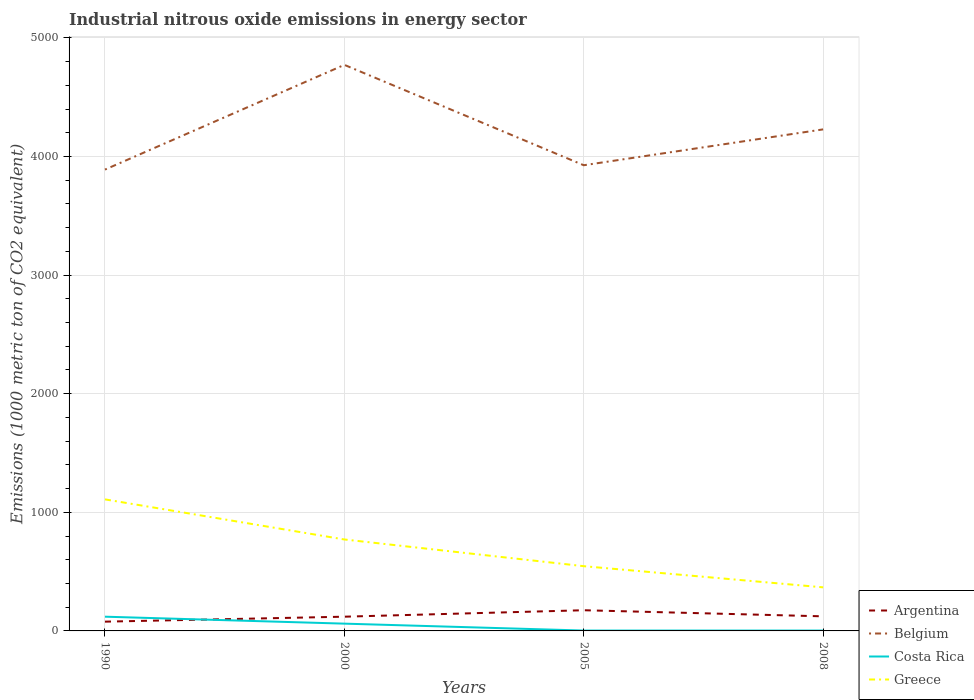Does the line corresponding to Belgium intersect with the line corresponding to Costa Rica?
Ensure brevity in your answer.  No. Is the number of lines equal to the number of legend labels?
Provide a short and direct response. Yes. Across all years, what is the maximum amount of industrial nitrous oxide emitted in Greece?
Offer a terse response. 367.4. What is the total amount of industrial nitrous oxide emitted in Belgium in the graph?
Keep it short and to the point. -339. What is the difference between the highest and the second highest amount of industrial nitrous oxide emitted in Greece?
Give a very brief answer. 741.7. How many years are there in the graph?
Give a very brief answer. 4. What is the difference between two consecutive major ticks on the Y-axis?
Make the answer very short. 1000. Does the graph contain grids?
Your answer should be compact. Yes. What is the title of the graph?
Offer a very short reply. Industrial nitrous oxide emissions in energy sector. What is the label or title of the X-axis?
Your response must be concise. Years. What is the label or title of the Y-axis?
Provide a succinct answer. Emissions (1000 metric ton of CO2 equivalent). What is the Emissions (1000 metric ton of CO2 equivalent) of Argentina in 1990?
Offer a very short reply. 78.1. What is the Emissions (1000 metric ton of CO2 equivalent) of Belgium in 1990?
Your answer should be very brief. 3889.6. What is the Emissions (1000 metric ton of CO2 equivalent) of Costa Rica in 1990?
Keep it short and to the point. 120. What is the Emissions (1000 metric ton of CO2 equivalent) of Greece in 1990?
Offer a very short reply. 1109.1. What is the Emissions (1000 metric ton of CO2 equivalent) of Argentina in 2000?
Your answer should be very brief. 120. What is the Emissions (1000 metric ton of CO2 equivalent) in Belgium in 2000?
Offer a terse response. 4772.6. What is the Emissions (1000 metric ton of CO2 equivalent) in Costa Rica in 2000?
Provide a short and direct response. 61.4. What is the Emissions (1000 metric ton of CO2 equivalent) in Greece in 2000?
Give a very brief answer. 771. What is the Emissions (1000 metric ton of CO2 equivalent) in Argentina in 2005?
Give a very brief answer. 174.4. What is the Emissions (1000 metric ton of CO2 equivalent) in Belgium in 2005?
Keep it short and to the point. 3926.3. What is the Emissions (1000 metric ton of CO2 equivalent) of Costa Rica in 2005?
Provide a short and direct response. 3.1. What is the Emissions (1000 metric ton of CO2 equivalent) of Greece in 2005?
Give a very brief answer. 545.8. What is the Emissions (1000 metric ton of CO2 equivalent) in Argentina in 2008?
Provide a short and direct response. 123. What is the Emissions (1000 metric ton of CO2 equivalent) of Belgium in 2008?
Offer a terse response. 4228.6. What is the Emissions (1000 metric ton of CO2 equivalent) in Greece in 2008?
Make the answer very short. 367.4. Across all years, what is the maximum Emissions (1000 metric ton of CO2 equivalent) of Argentina?
Offer a very short reply. 174.4. Across all years, what is the maximum Emissions (1000 metric ton of CO2 equivalent) in Belgium?
Offer a very short reply. 4772.6. Across all years, what is the maximum Emissions (1000 metric ton of CO2 equivalent) in Costa Rica?
Offer a terse response. 120. Across all years, what is the maximum Emissions (1000 metric ton of CO2 equivalent) in Greece?
Offer a very short reply. 1109.1. Across all years, what is the minimum Emissions (1000 metric ton of CO2 equivalent) in Argentina?
Your answer should be very brief. 78.1. Across all years, what is the minimum Emissions (1000 metric ton of CO2 equivalent) of Belgium?
Ensure brevity in your answer.  3889.6. Across all years, what is the minimum Emissions (1000 metric ton of CO2 equivalent) of Costa Rica?
Your answer should be very brief. 3.1. Across all years, what is the minimum Emissions (1000 metric ton of CO2 equivalent) in Greece?
Keep it short and to the point. 367.4. What is the total Emissions (1000 metric ton of CO2 equivalent) in Argentina in the graph?
Offer a terse response. 495.5. What is the total Emissions (1000 metric ton of CO2 equivalent) of Belgium in the graph?
Provide a succinct answer. 1.68e+04. What is the total Emissions (1000 metric ton of CO2 equivalent) in Costa Rica in the graph?
Offer a terse response. 187.6. What is the total Emissions (1000 metric ton of CO2 equivalent) of Greece in the graph?
Your answer should be very brief. 2793.3. What is the difference between the Emissions (1000 metric ton of CO2 equivalent) of Argentina in 1990 and that in 2000?
Your answer should be very brief. -41.9. What is the difference between the Emissions (1000 metric ton of CO2 equivalent) in Belgium in 1990 and that in 2000?
Provide a short and direct response. -883. What is the difference between the Emissions (1000 metric ton of CO2 equivalent) of Costa Rica in 1990 and that in 2000?
Ensure brevity in your answer.  58.6. What is the difference between the Emissions (1000 metric ton of CO2 equivalent) in Greece in 1990 and that in 2000?
Make the answer very short. 338.1. What is the difference between the Emissions (1000 metric ton of CO2 equivalent) of Argentina in 1990 and that in 2005?
Your answer should be very brief. -96.3. What is the difference between the Emissions (1000 metric ton of CO2 equivalent) of Belgium in 1990 and that in 2005?
Offer a very short reply. -36.7. What is the difference between the Emissions (1000 metric ton of CO2 equivalent) in Costa Rica in 1990 and that in 2005?
Your answer should be compact. 116.9. What is the difference between the Emissions (1000 metric ton of CO2 equivalent) in Greece in 1990 and that in 2005?
Your response must be concise. 563.3. What is the difference between the Emissions (1000 metric ton of CO2 equivalent) of Argentina in 1990 and that in 2008?
Offer a terse response. -44.9. What is the difference between the Emissions (1000 metric ton of CO2 equivalent) in Belgium in 1990 and that in 2008?
Your answer should be compact. -339. What is the difference between the Emissions (1000 metric ton of CO2 equivalent) in Costa Rica in 1990 and that in 2008?
Offer a terse response. 116.9. What is the difference between the Emissions (1000 metric ton of CO2 equivalent) of Greece in 1990 and that in 2008?
Give a very brief answer. 741.7. What is the difference between the Emissions (1000 metric ton of CO2 equivalent) in Argentina in 2000 and that in 2005?
Give a very brief answer. -54.4. What is the difference between the Emissions (1000 metric ton of CO2 equivalent) of Belgium in 2000 and that in 2005?
Offer a terse response. 846.3. What is the difference between the Emissions (1000 metric ton of CO2 equivalent) of Costa Rica in 2000 and that in 2005?
Keep it short and to the point. 58.3. What is the difference between the Emissions (1000 metric ton of CO2 equivalent) in Greece in 2000 and that in 2005?
Offer a very short reply. 225.2. What is the difference between the Emissions (1000 metric ton of CO2 equivalent) in Belgium in 2000 and that in 2008?
Your answer should be compact. 544. What is the difference between the Emissions (1000 metric ton of CO2 equivalent) of Costa Rica in 2000 and that in 2008?
Offer a terse response. 58.3. What is the difference between the Emissions (1000 metric ton of CO2 equivalent) in Greece in 2000 and that in 2008?
Your answer should be compact. 403.6. What is the difference between the Emissions (1000 metric ton of CO2 equivalent) in Argentina in 2005 and that in 2008?
Provide a short and direct response. 51.4. What is the difference between the Emissions (1000 metric ton of CO2 equivalent) of Belgium in 2005 and that in 2008?
Keep it short and to the point. -302.3. What is the difference between the Emissions (1000 metric ton of CO2 equivalent) in Costa Rica in 2005 and that in 2008?
Give a very brief answer. 0. What is the difference between the Emissions (1000 metric ton of CO2 equivalent) of Greece in 2005 and that in 2008?
Give a very brief answer. 178.4. What is the difference between the Emissions (1000 metric ton of CO2 equivalent) of Argentina in 1990 and the Emissions (1000 metric ton of CO2 equivalent) of Belgium in 2000?
Offer a terse response. -4694.5. What is the difference between the Emissions (1000 metric ton of CO2 equivalent) of Argentina in 1990 and the Emissions (1000 metric ton of CO2 equivalent) of Costa Rica in 2000?
Keep it short and to the point. 16.7. What is the difference between the Emissions (1000 metric ton of CO2 equivalent) of Argentina in 1990 and the Emissions (1000 metric ton of CO2 equivalent) of Greece in 2000?
Provide a short and direct response. -692.9. What is the difference between the Emissions (1000 metric ton of CO2 equivalent) of Belgium in 1990 and the Emissions (1000 metric ton of CO2 equivalent) of Costa Rica in 2000?
Provide a succinct answer. 3828.2. What is the difference between the Emissions (1000 metric ton of CO2 equivalent) of Belgium in 1990 and the Emissions (1000 metric ton of CO2 equivalent) of Greece in 2000?
Offer a very short reply. 3118.6. What is the difference between the Emissions (1000 metric ton of CO2 equivalent) of Costa Rica in 1990 and the Emissions (1000 metric ton of CO2 equivalent) of Greece in 2000?
Provide a succinct answer. -651. What is the difference between the Emissions (1000 metric ton of CO2 equivalent) in Argentina in 1990 and the Emissions (1000 metric ton of CO2 equivalent) in Belgium in 2005?
Ensure brevity in your answer.  -3848.2. What is the difference between the Emissions (1000 metric ton of CO2 equivalent) in Argentina in 1990 and the Emissions (1000 metric ton of CO2 equivalent) in Costa Rica in 2005?
Offer a terse response. 75. What is the difference between the Emissions (1000 metric ton of CO2 equivalent) of Argentina in 1990 and the Emissions (1000 metric ton of CO2 equivalent) of Greece in 2005?
Your answer should be compact. -467.7. What is the difference between the Emissions (1000 metric ton of CO2 equivalent) of Belgium in 1990 and the Emissions (1000 metric ton of CO2 equivalent) of Costa Rica in 2005?
Make the answer very short. 3886.5. What is the difference between the Emissions (1000 metric ton of CO2 equivalent) in Belgium in 1990 and the Emissions (1000 metric ton of CO2 equivalent) in Greece in 2005?
Make the answer very short. 3343.8. What is the difference between the Emissions (1000 metric ton of CO2 equivalent) of Costa Rica in 1990 and the Emissions (1000 metric ton of CO2 equivalent) of Greece in 2005?
Keep it short and to the point. -425.8. What is the difference between the Emissions (1000 metric ton of CO2 equivalent) of Argentina in 1990 and the Emissions (1000 metric ton of CO2 equivalent) of Belgium in 2008?
Ensure brevity in your answer.  -4150.5. What is the difference between the Emissions (1000 metric ton of CO2 equivalent) in Argentina in 1990 and the Emissions (1000 metric ton of CO2 equivalent) in Costa Rica in 2008?
Offer a very short reply. 75. What is the difference between the Emissions (1000 metric ton of CO2 equivalent) of Argentina in 1990 and the Emissions (1000 metric ton of CO2 equivalent) of Greece in 2008?
Ensure brevity in your answer.  -289.3. What is the difference between the Emissions (1000 metric ton of CO2 equivalent) in Belgium in 1990 and the Emissions (1000 metric ton of CO2 equivalent) in Costa Rica in 2008?
Give a very brief answer. 3886.5. What is the difference between the Emissions (1000 metric ton of CO2 equivalent) of Belgium in 1990 and the Emissions (1000 metric ton of CO2 equivalent) of Greece in 2008?
Your response must be concise. 3522.2. What is the difference between the Emissions (1000 metric ton of CO2 equivalent) of Costa Rica in 1990 and the Emissions (1000 metric ton of CO2 equivalent) of Greece in 2008?
Offer a terse response. -247.4. What is the difference between the Emissions (1000 metric ton of CO2 equivalent) of Argentina in 2000 and the Emissions (1000 metric ton of CO2 equivalent) of Belgium in 2005?
Offer a terse response. -3806.3. What is the difference between the Emissions (1000 metric ton of CO2 equivalent) in Argentina in 2000 and the Emissions (1000 metric ton of CO2 equivalent) in Costa Rica in 2005?
Ensure brevity in your answer.  116.9. What is the difference between the Emissions (1000 metric ton of CO2 equivalent) of Argentina in 2000 and the Emissions (1000 metric ton of CO2 equivalent) of Greece in 2005?
Offer a very short reply. -425.8. What is the difference between the Emissions (1000 metric ton of CO2 equivalent) of Belgium in 2000 and the Emissions (1000 metric ton of CO2 equivalent) of Costa Rica in 2005?
Offer a very short reply. 4769.5. What is the difference between the Emissions (1000 metric ton of CO2 equivalent) in Belgium in 2000 and the Emissions (1000 metric ton of CO2 equivalent) in Greece in 2005?
Give a very brief answer. 4226.8. What is the difference between the Emissions (1000 metric ton of CO2 equivalent) of Costa Rica in 2000 and the Emissions (1000 metric ton of CO2 equivalent) of Greece in 2005?
Give a very brief answer. -484.4. What is the difference between the Emissions (1000 metric ton of CO2 equivalent) of Argentina in 2000 and the Emissions (1000 metric ton of CO2 equivalent) of Belgium in 2008?
Offer a terse response. -4108.6. What is the difference between the Emissions (1000 metric ton of CO2 equivalent) of Argentina in 2000 and the Emissions (1000 metric ton of CO2 equivalent) of Costa Rica in 2008?
Your answer should be compact. 116.9. What is the difference between the Emissions (1000 metric ton of CO2 equivalent) in Argentina in 2000 and the Emissions (1000 metric ton of CO2 equivalent) in Greece in 2008?
Your answer should be compact. -247.4. What is the difference between the Emissions (1000 metric ton of CO2 equivalent) of Belgium in 2000 and the Emissions (1000 metric ton of CO2 equivalent) of Costa Rica in 2008?
Keep it short and to the point. 4769.5. What is the difference between the Emissions (1000 metric ton of CO2 equivalent) of Belgium in 2000 and the Emissions (1000 metric ton of CO2 equivalent) of Greece in 2008?
Ensure brevity in your answer.  4405.2. What is the difference between the Emissions (1000 metric ton of CO2 equivalent) in Costa Rica in 2000 and the Emissions (1000 metric ton of CO2 equivalent) in Greece in 2008?
Give a very brief answer. -306. What is the difference between the Emissions (1000 metric ton of CO2 equivalent) in Argentina in 2005 and the Emissions (1000 metric ton of CO2 equivalent) in Belgium in 2008?
Your answer should be compact. -4054.2. What is the difference between the Emissions (1000 metric ton of CO2 equivalent) in Argentina in 2005 and the Emissions (1000 metric ton of CO2 equivalent) in Costa Rica in 2008?
Keep it short and to the point. 171.3. What is the difference between the Emissions (1000 metric ton of CO2 equivalent) of Argentina in 2005 and the Emissions (1000 metric ton of CO2 equivalent) of Greece in 2008?
Provide a succinct answer. -193. What is the difference between the Emissions (1000 metric ton of CO2 equivalent) of Belgium in 2005 and the Emissions (1000 metric ton of CO2 equivalent) of Costa Rica in 2008?
Keep it short and to the point. 3923.2. What is the difference between the Emissions (1000 metric ton of CO2 equivalent) of Belgium in 2005 and the Emissions (1000 metric ton of CO2 equivalent) of Greece in 2008?
Provide a short and direct response. 3558.9. What is the difference between the Emissions (1000 metric ton of CO2 equivalent) in Costa Rica in 2005 and the Emissions (1000 metric ton of CO2 equivalent) in Greece in 2008?
Provide a succinct answer. -364.3. What is the average Emissions (1000 metric ton of CO2 equivalent) of Argentina per year?
Make the answer very short. 123.88. What is the average Emissions (1000 metric ton of CO2 equivalent) of Belgium per year?
Provide a short and direct response. 4204.27. What is the average Emissions (1000 metric ton of CO2 equivalent) of Costa Rica per year?
Your answer should be very brief. 46.9. What is the average Emissions (1000 metric ton of CO2 equivalent) in Greece per year?
Offer a terse response. 698.33. In the year 1990, what is the difference between the Emissions (1000 metric ton of CO2 equivalent) in Argentina and Emissions (1000 metric ton of CO2 equivalent) in Belgium?
Keep it short and to the point. -3811.5. In the year 1990, what is the difference between the Emissions (1000 metric ton of CO2 equivalent) of Argentina and Emissions (1000 metric ton of CO2 equivalent) of Costa Rica?
Ensure brevity in your answer.  -41.9. In the year 1990, what is the difference between the Emissions (1000 metric ton of CO2 equivalent) of Argentina and Emissions (1000 metric ton of CO2 equivalent) of Greece?
Offer a very short reply. -1031. In the year 1990, what is the difference between the Emissions (1000 metric ton of CO2 equivalent) in Belgium and Emissions (1000 metric ton of CO2 equivalent) in Costa Rica?
Offer a terse response. 3769.6. In the year 1990, what is the difference between the Emissions (1000 metric ton of CO2 equivalent) of Belgium and Emissions (1000 metric ton of CO2 equivalent) of Greece?
Your response must be concise. 2780.5. In the year 1990, what is the difference between the Emissions (1000 metric ton of CO2 equivalent) of Costa Rica and Emissions (1000 metric ton of CO2 equivalent) of Greece?
Provide a succinct answer. -989.1. In the year 2000, what is the difference between the Emissions (1000 metric ton of CO2 equivalent) in Argentina and Emissions (1000 metric ton of CO2 equivalent) in Belgium?
Ensure brevity in your answer.  -4652.6. In the year 2000, what is the difference between the Emissions (1000 metric ton of CO2 equivalent) in Argentina and Emissions (1000 metric ton of CO2 equivalent) in Costa Rica?
Your answer should be very brief. 58.6. In the year 2000, what is the difference between the Emissions (1000 metric ton of CO2 equivalent) in Argentina and Emissions (1000 metric ton of CO2 equivalent) in Greece?
Offer a terse response. -651. In the year 2000, what is the difference between the Emissions (1000 metric ton of CO2 equivalent) of Belgium and Emissions (1000 metric ton of CO2 equivalent) of Costa Rica?
Keep it short and to the point. 4711.2. In the year 2000, what is the difference between the Emissions (1000 metric ton of CO2 equivalent) in Belgium and Emissions (1000 metric ton of CO2 equivalent) in Greece?
Provide a succinct answer. 4001.6. In the year 2000, what is the difference between the Emissions (1000 metric ton of CO2 equivalent) of Costa Rica and Emissions (1000 metric ton of CO2 equivalent) of Greece?
Offer a very short reply. -709.6. In the year 2005, what is the difference between the Emissions (1000 metric ton of CO2 equivalent) of Argentina and Emissions (1000 metric ton of CO2 equivalent) of Belgium?
Offer a very short reply. -3751.9. In the year 2005, what is the difference between the Emissions (1000 metric ton of CO2 equivalent) in Argentina and Emissions (1000 metric ton of CO2 equivalent) in Costa Rica?
Your response must be concise. 171.3. In the year 2005, what is the difference between the Emissions (1000 metric ton of CO2 equivalent) of Argentina and Emissions (1000 metric ton of CO2 equivalent) of Greece?
Make the answer very short. -371.4. In the year 2005, what is the difference between the Emissions (1000 metric ton of CO2 equivalent) in Belgium and Emissions (1000 metric ton of CO2 equivalent) in Costa Rica?
Ensure brevity in your answer.  3923.2. In the year 2005, what is the difference between the Emissions (1000 metric ton of CO2 equivalent) in Belgium and Emissions (1000 metric ton of CO2 equivalent) in Greece?
Offer a terse response. 3380.5. In the year 2005, what is the difference between the Emissions (1000 metric ton of CO2 equivalent) of Costa Rica and Emissions (1000 metric ton of CO2 equivalent) of Greece?
Offer a very short reply. -542.7. In the year 2008, what is the difference between the Emissions (1000 metric ton of CO2 equivalent) of Argentina and Emissions (1000 metric ton of CO2 equivalent) of Belgium?
Offer a very short reply. -4105.6. In the year 2008, what is the difference between the Emissions (1000 metric ton of CO2 equivalent) in Argentina and Emissions (1000 metric ton of CO2 equivalent) in Costa Rica?
Keep it short and to the point. 119.9. In the year 2008, what is the difference between the Emissions (1000 metric ton of CO2 equivalent) in Argentina and Emissions (1000 metric ton of CO2 equivalent) in Greece?
Keep it short and to the point. -244.4. In the year 2008, what is the difference between the Emissions (1000 metric ton of CO2 equivalent) of Belgium and Emissions (1000 metric ton of CO2 equivalent) of Costa Rica?
Offer a terse response. 4225.5. In the year 2008, what is the difference between the Emissions (1000 metric ton of CO2 equivalent) of Belgium and Emissions (1000 metric ton of CO2 equivalent) of Greece?
Give a very brief answer. 3861.2. In the year 2008, what is the difference between the Emissions (1000 metric ton of CO2 equivalent) of Costa Rica and Emissions (1000 metric ton of CO2 equivalent) of Greece?
Offer a terse response. -364.3. What is the ratio of the Emissions (1000 metric ton of CO2 equivalent) in Argentina in 1990 to that in 2000?
Your answer should be very brief. 0.65. What is the ratio of the Emissions (1000 metric ton of CO2 equivalent) in Belgium in 1990 to that in 2000?
Ensure brevity in your answer.  0.81. What is the ratio of the Emissions (1000 metric ton of CO2 equivalent) in Costa Rica in 1990 to that in 2000?
Provide a succinct answer. 1.95. What is the ratio of the Emissions (1000 metric ton of CO2 equivalent) of Greece in 1990 to that in 2000?
Your answer should be very brief. 1.44. What is the ratio of the Emissions (1000 metric ton of CO2 equivalent) of Argentina in 1990 to that in 2005?
Offer a very short reply. 0.45. What is the ratio of the Emissions (1000 metric ton of CO2 equivalent) of Costa Rica in 1990 to that in 2005?
Ensure brevity in your answer.  38.71. What is the ratio of the Emissions (1000 metric ton of CO2 equivalent) in Greece in 1990 to that in 2005?
Offer a very short reply. 2.03. What is the ratio of the Emissions (1000 metric ton of CO2 equivalent) in Argentina in 1990 to that in 2008?
Offer a very short reply. 0.64. What is the ratio of the Emissions (1000 metric ton of CO2 equivalent) of Belgium in 1990 to that in 2008?
Provide a succinct answer. 0.92. What is the ratio of the Emissions (1000 metric ton of CO2 equivalent) in Costa Rica in 1990 to that in 2008?
Provide a succinct answer. 38.71. What is the ratio of the Emissions (1000 metric ton of CO2 equivalent) in Greece in 1990 to that in 2008?
Your answer should be compact. 3.02. What is the ratio of the Emissions (1000 metric ton of CO2 equivalent) in Argentina in 2000 to that in 2005?
Offer a terse response. 0.69. What is the ratio of the Emissions (1000 metric ton of CO2 equivalent) in Belgium in 2000 to that in 2005?
Your answer should be very brief. 1.22. What is the ratio of the Emissions (1000 metric ton of CO2 equivalent) in Costa Rica in 2000 to that in 2005?
Give a very brief answer. 19.81. What is the ratio of the Emissions (1000 metric ton of CO2 equivalent) in Greece in 2000 to that in 2005?
Ensure brevity in your answer.  1.41. What is the ratio of the Emissions (1000 metric ton of CO2 equivalent) in Argentina in 2000 to that in 2008?
Make the answer very short. 0.98. What is the ratio of the Emissions (1000 metric ton of CO2 equivalent) in Belgium in 2000 to that in 2008?
Offer a terse response. 1.13. What is the ratio of the Emissions (1000 metric ton of CO2 equivalent) of Costa Rica in 2000 to that in 2008?
Ensure brevity in your answer.  19.81. What is the ratio of the Emissions (1000 metric ton of CO2 equivalent) in Greece in 2000 to that in 2008?
Make the answer very short. 2.1. What is the ratio of the Emissions (1000 metric ton of CO2 equivalent) in Argentina in 2005 to that in 2008?
Keep it short and to the point. 1.42. What is the ratio of the Emissions (1000 metric ton of CO2 equivalent) of Belgium in 2005 to that in 2008?
Make the answer very short. 0.93. What is the ratio of the Emissions (1000 metric ton of CO2 equivalent) of Costa Rica in 2005 to that in 2008?
Your response must be concise. 1. What is the ratio of the Emissions (1000 metric ton of CO2 equivalent) in Greece in 2005 to that in 2008?
Ensure brevity in your answer.  1.49. What is the difference between the highest and the second highest Emissions (1000 metric ton of CO2 equivalent) in Argentina?
Give a very brief answer. 51.4. What is the difference between the highest and the second highest Emissions (1000 metric ton of CO2 equivalent) of Belgium?
Offer a terse response. 544. What is the difference between the highest and the second highest Emissions (1000 metric ton of CO2 equivalent) in Costa Rica?
Keep it short and to the point. 58.6. What is the difference between the highest and the second highest Emissions (1000 metric ton of CO2 equivalent) of Greece?
Ensure brevity in your answer.  338.1. What is the difference between the highest and the lowest Emissions (1000 metric ton of CO2 equivalent) in Argentina?
Offer a very short reply. 96.3. What is the difference between the highest and the lowest Emissions (1000 metric ton of CO2 equivalent) in Belgium?
Provide a short and direct response. 883. What is the difference between the highest and the lowest Emissions (1000 metric ton of CO2 equivalent) of Costa Rica?
Make the answer very short. 116.9. What is the difference between the highest and the lowest Emissions (1000 metric ton of CO2 equivalent) in Greece?
Make the answer very short. 741.7. 